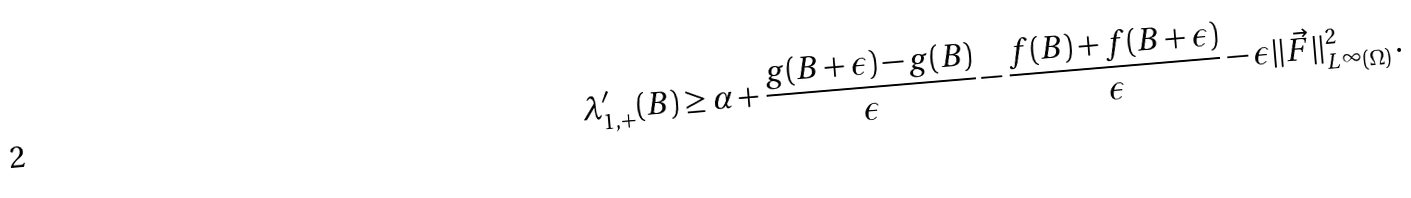Convert formula to latex. <formula><loc_0><loc_0><loc_500><loc_500>\lambda _ { 1 , + } ^ { \prime } ( B ) \geq \alpha + \frac { g ( B + \epsilon ) - g ( B ) } { \epsilon } - \frac { f ( B ) + f ( B + \epsilon ) } { \epsilon } - \epsilon \| \vec { F } \| _ { L ^ { \infty } ( \Omega ) } ^ { 2 } \, .</formula> 